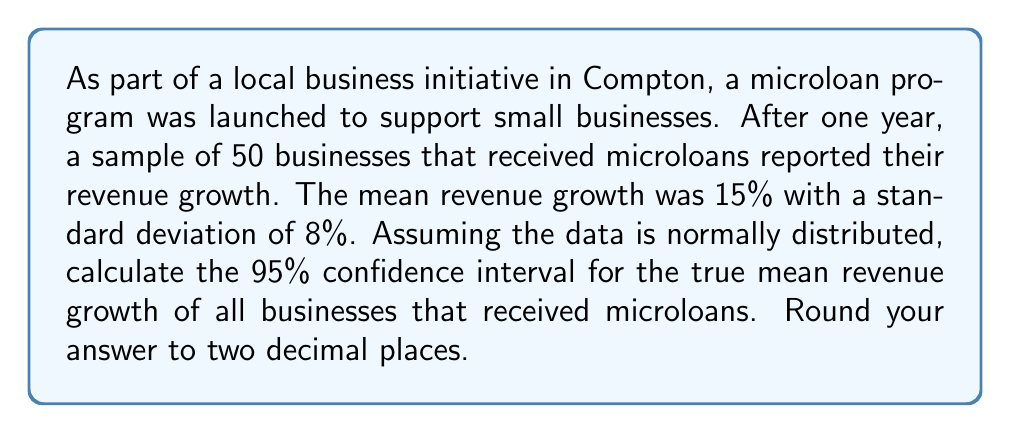Help me with this question. To calculate the confidence interval, we'll use the formula:

$$ \text{CI} = \bar{x} \pm t_{\alpha/2} \cdot \frac{s}{\sqrt{n}} $$

Where:
$\bar{x}$ = sample mean = 15%
$s$ = sample standard deviation = 8%
$n$ = sample size = 50
$t_{\alpha/2}$ = t-value for 95% confidence interval with 49 degrees of freedom

Steps:
1) Find $t_{\alpha/2}$:
   For 95% CI and 49 df, $t_{\alpha/2} \approx 2.01$ (from t-distribution table)

2) Calculate standard error:
   $SE = \frac{s}{\sqrt{n}} = \frac{8}{\sqrt{50}} = 1.13$

3) Calculate margin of error:
   $ME = t_{\alpha/2} \cdot SE = 2.01 \cdot 1.13 = 2.27$

4) Calculate confidence interval:
   $CI = 15 \pm 2.27$
   Lower bound: $15 - 2.27 = 12.73$
   Upper bound: $15 + 2.27 = 17.27$

5) Round to two decimal places:
   $CI = (12.73, 17.27)$
Answer: (12.73%, 17.27%) 